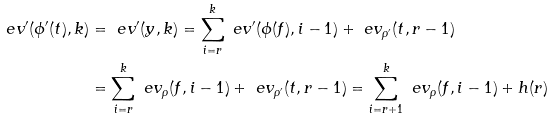<formula> <loc_0><loc_0><loc_500><loc_500>\ e v ^ { \prime } ( \phi ^ { \prime } ( t ) , k ) & = \ e v ^ { \prime } ( y , k ) = \sum _ { i = r } ^ { k } \ e v ^ { \prime } ( \phi ( f ) , i - 1 ) + \ e v _ { \rho ^ { \prime } } ( t , r - 1 ) \\ & = \sum _ { i = r } ^ { k } \ e v _ { \rho } ( f , i - 1 ) + \ e v _ { \rho ^ { \prime } } ( t , r - 1 ) = \sum _ { i = r + 1 } ^ { k } \ e v _ { \rho } ( f , i - 1 ) + h ( r )</formula> 